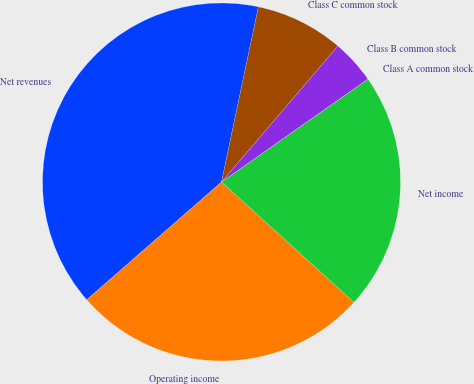<chart> <loc_0><loc_0><loc_500><loc_500><pie_chart><fcel>Net revenues<fcel>Operating income<fcel>Net income<fcel>Class A common stock<fcel>Class B common stock<fcel>Class C common stock<nl><fcel>39.74%<fcel>26.83%<fcel>21.49%<fcel>0.01%<fcel>3.98%<fcel>7.96%<nl></chart> 